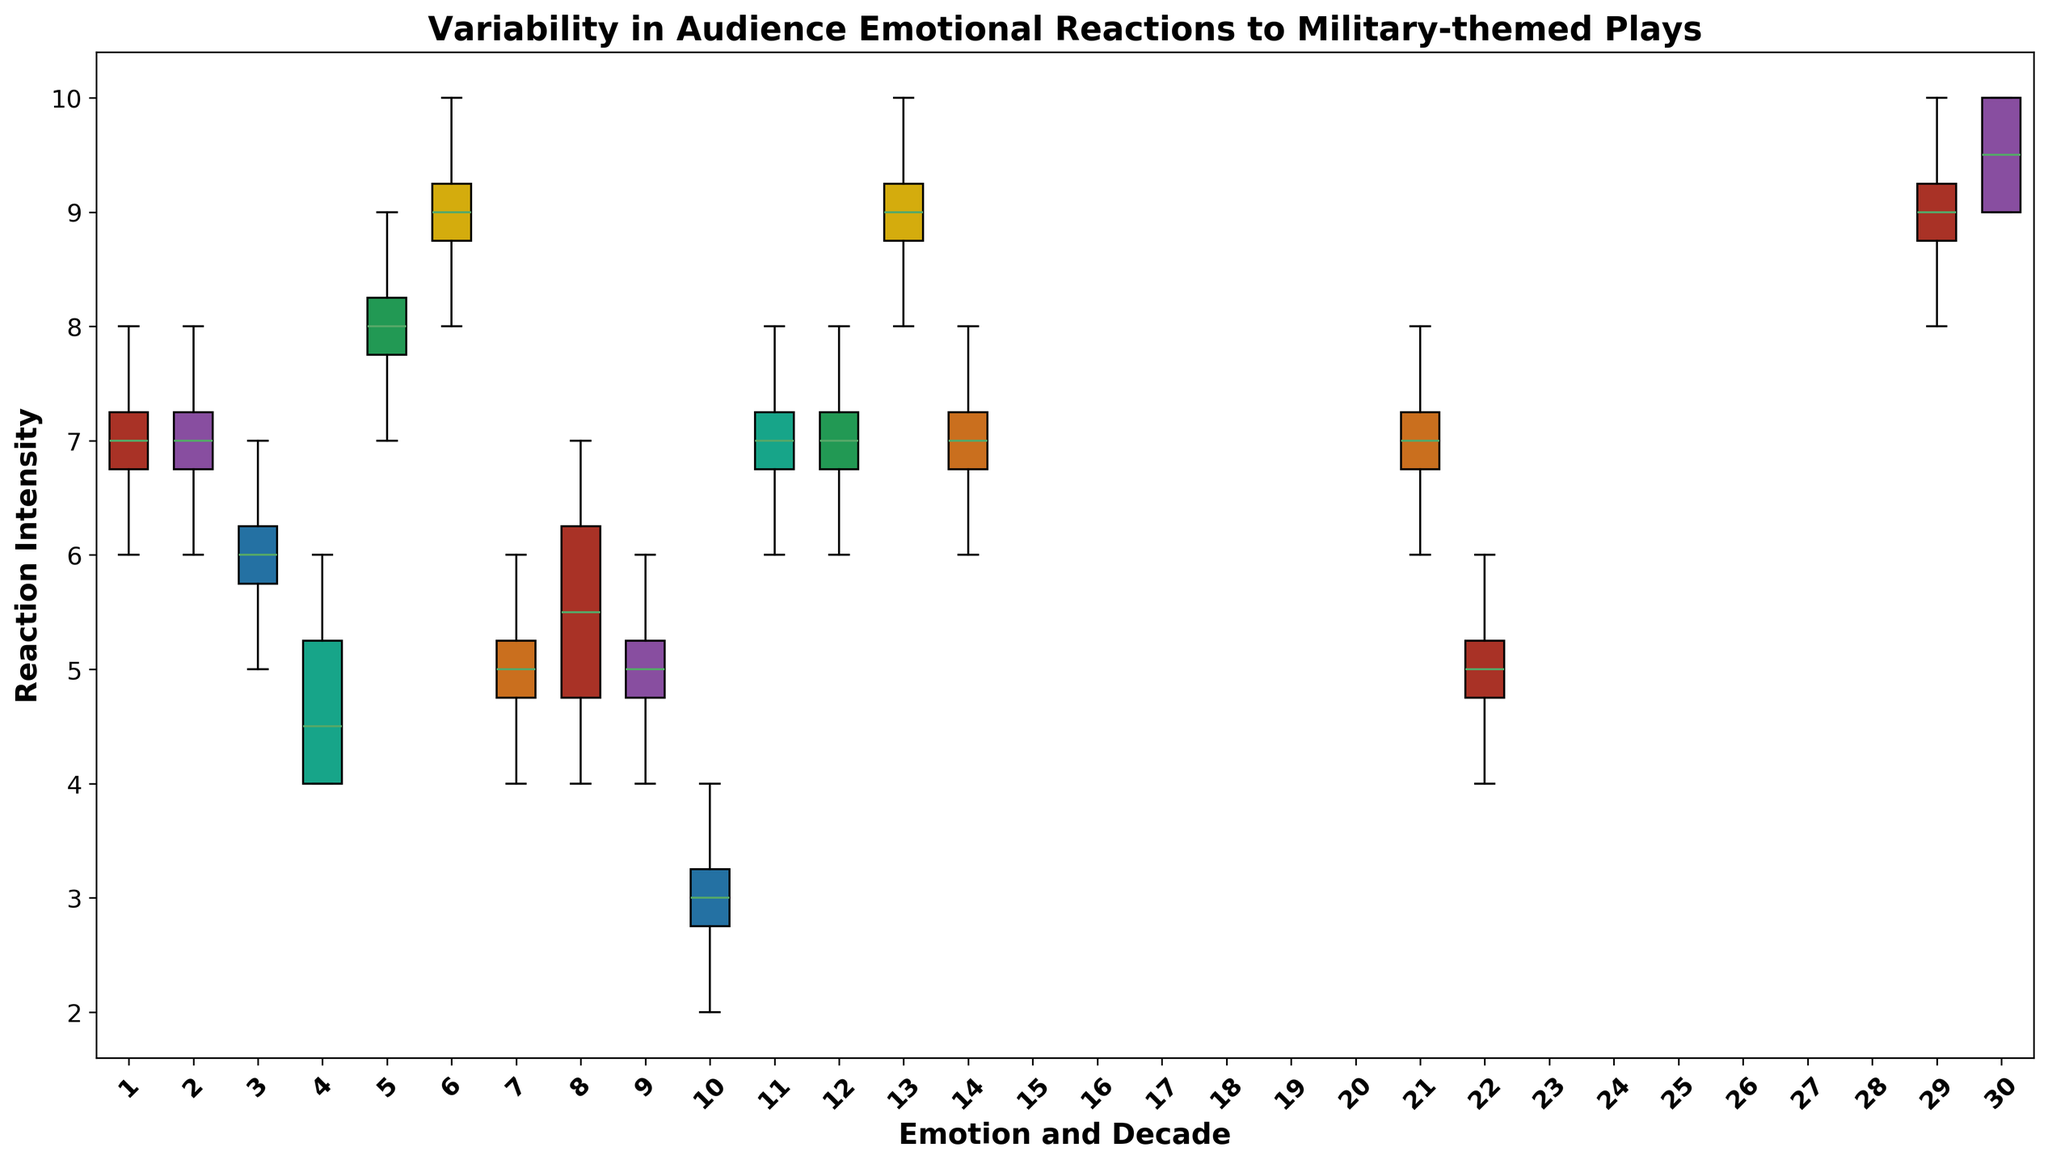Which decade and emotion combination has the highest median reaction intensity? To find the highest median reaction, we need to look at the boxes in the box plot and identify the combination with the highest center line (median).
Answer: 2010s and Anxiety Which emotion showed the greatest variability in reaction intensity during the 1960s? We assess variability by the height of the boxes. The taller the box, the greater the variability. For the 1960s, we compare Fear, Sadness, and Patriotism.
Answer: Patriotism How does the median reaction intensity in the 1970s for Fear compare to the 1990s for Fear? To compare the medians, we locate the center lines of the boxes for Fear in the 1970s and 1990s.
Answer: 1970s median is higher than 1990s Is the interquartile range (IQR) for Anger in the 1980s greater than the IQR for Sadness in the 1980s? IQR is the range between the first and third quartile. Measure the height between these points for both emotions in the 1980s.
Answer: Yes Which emotion in the 2000s has the most consistent (least variable) reaction intensity, and how can you tell? Consistency is indicated by the shortest box. We compare the height of the boxes for Fear, Sadness, and Anxiety in the 2000s.
Answer: Sadness, because it has the shortest box For which decade and emotion combination is the range of reaction intensities the widest? The range is the distance between the top and bottom whiskers. Identify the largest range by comparing all combinations.
Answer: 2010s and Anxiety Do Sadness reactions in the 1990s have any outliers, and how do you know? Outliers are typically represented by points outside the whiskers. Check for any points outside the whiskers in the Sadness box for the 1990s.
Answer: No outliers Compare the median reaction intensity for Sadness between the 1960s and 2010s. Locate and compare the center lines of the Sadness boxes for both decades.
Answer: 2010s median is higher than 1960s Is the reaction intensity for Fear in the 2000s more variable than in the 2010s? Compare the height of the boxes (IQR) for Fear in both decades.
Answer: No Which emotion in the 1980s has the highest median reaction intensity? Look for the emotion in the 1980s that has the highest center line in its box.
Answer: Anger 